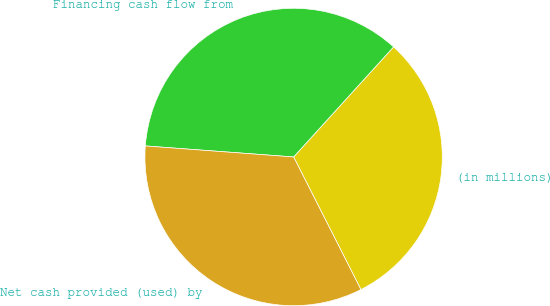Convert chart to OTSL. <chart><loc_0><loc_0><loc_500><loc_500><pie_chart><fcel>(in millions)<fcel>Financing cash flow from<fcel>Net cash provided (used) by<nl><fcel>30.79%<fcel>35.55%<fcel>33.66%<nl></chart> 